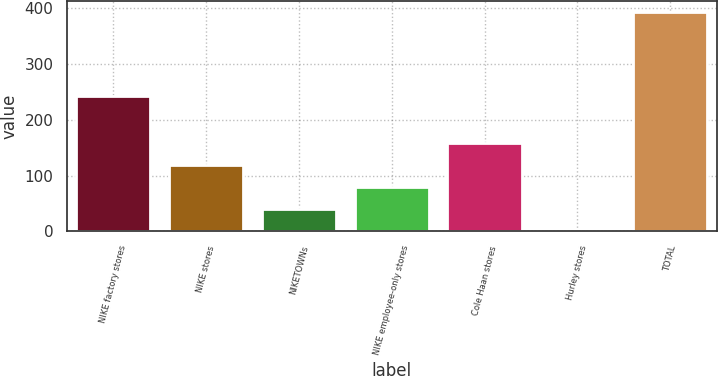Convert chart. <chart><loc_0><loc_0><loc_500><loc_500><bar_chart><fcel>NIKE factory stores<fcel>NIKE stores<fcel>NIKETOWNs<fcel>NIKE employee-only stores<fcel>Cole Haan stores<fcel>Hurley stores<fcel>TOTAL<nl><fcel>243<fcel>118.6<fcel>40.2<fcel>79.4<fcel>157.8<fcel>1<fcel>393<nl></chart> 